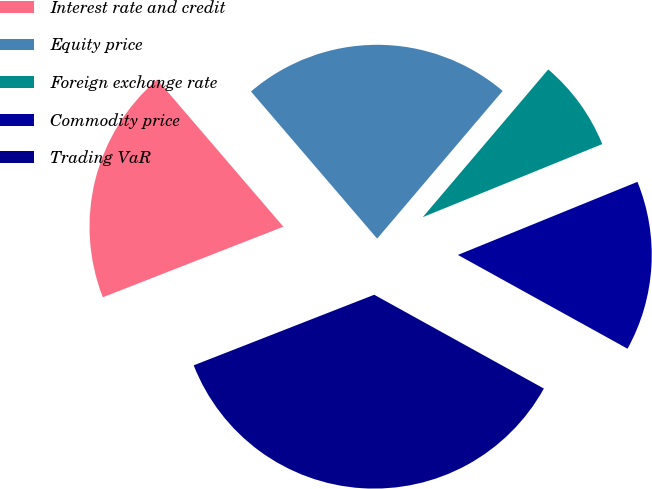Convert chart to OTSL. <chart><loc_0><loc_0><loc_500><loc_500><pie_chart><fcel>Interest rate and credit<fcel>Equity price<fcel>Foreign exchange rate<fcel>Commodity price<fcel>Trading VaR<nl><fcel>19.65%<fcel>22.49%<fcel>7.64%<fcel>14.19%<fcel>36.03%<nl></chart> 